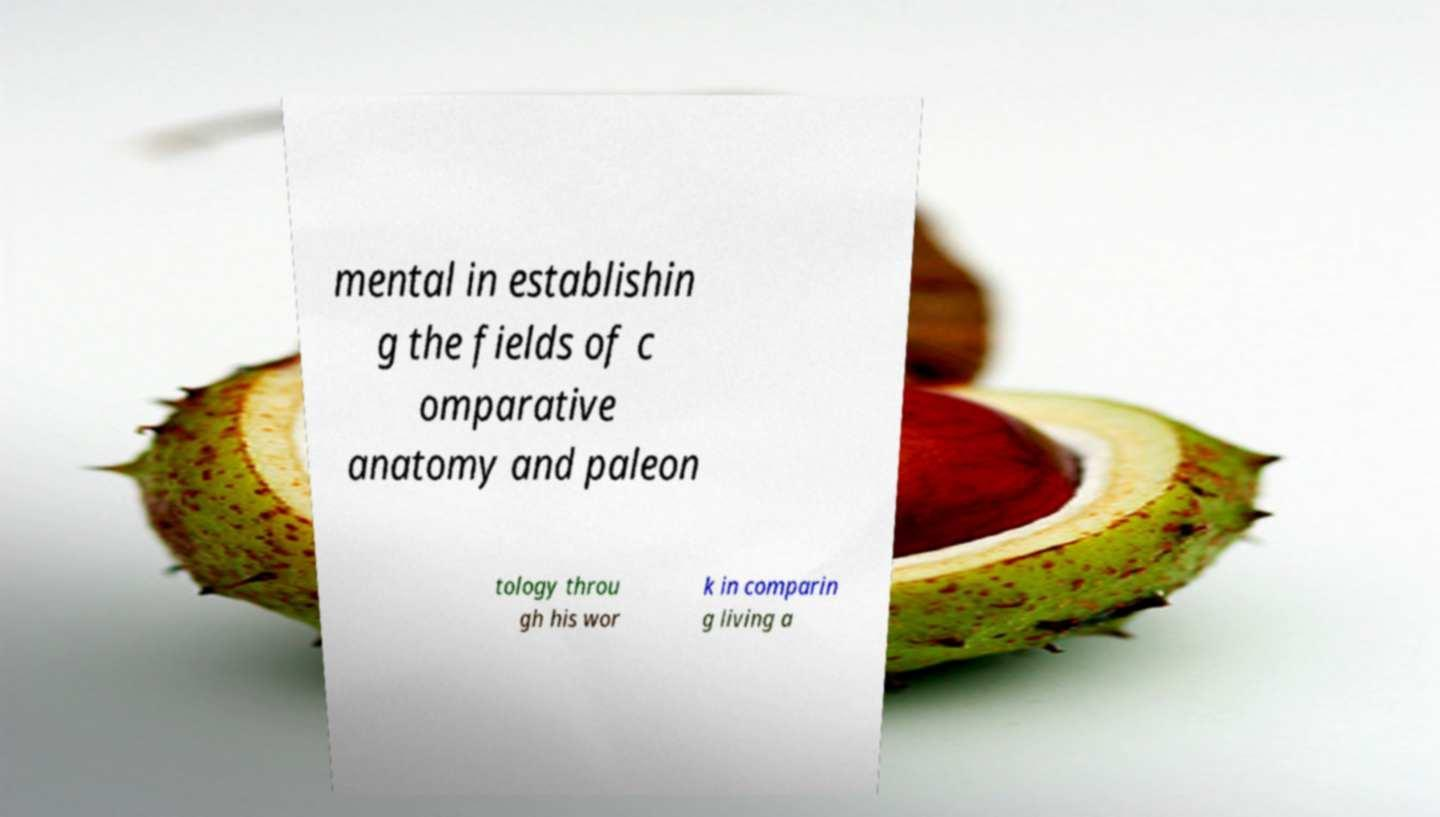Can you read and provide the text displayed in the image?This photo seems to have some interesting text. Can you extract and type it out for me? mental in establishin g the fields of c omparative anatomy and paleon tology throu gh his wor k in comparin g living a 